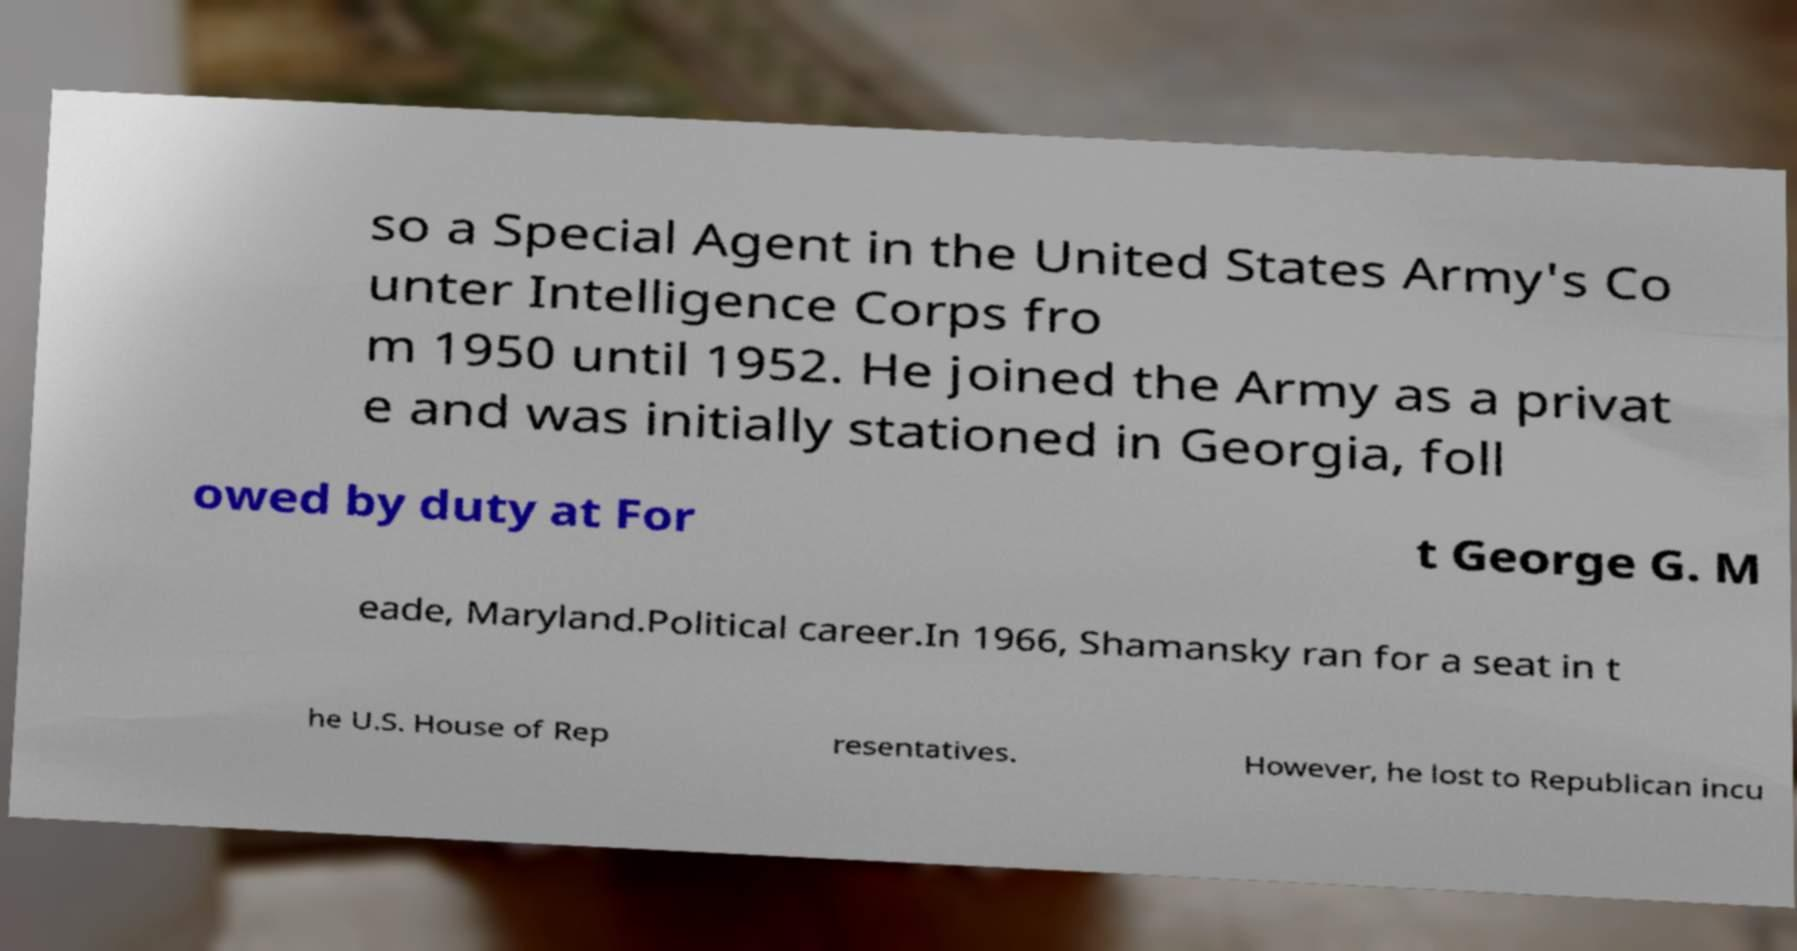Could you assist in decoding the text presented in this image and type it out clearly? so a Special Agent in the United States Army's Co unter Intelligence Corps fro m 1950 until 1952. He joined the Army as a privat e and was initially stationed in Georgia, foll owed by duty at For t George G. M eade, Maryland.Political career.In 1966, Shamansky ran for a seat in t he U.S. House of Rep resentatives. However, he lost to Republican incu 